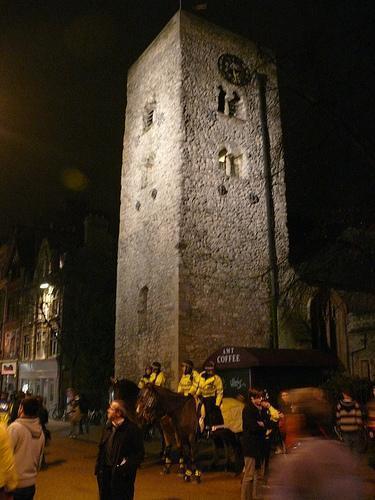How many windows are visible on the tallest building?
Give a very brief answer. 5. 